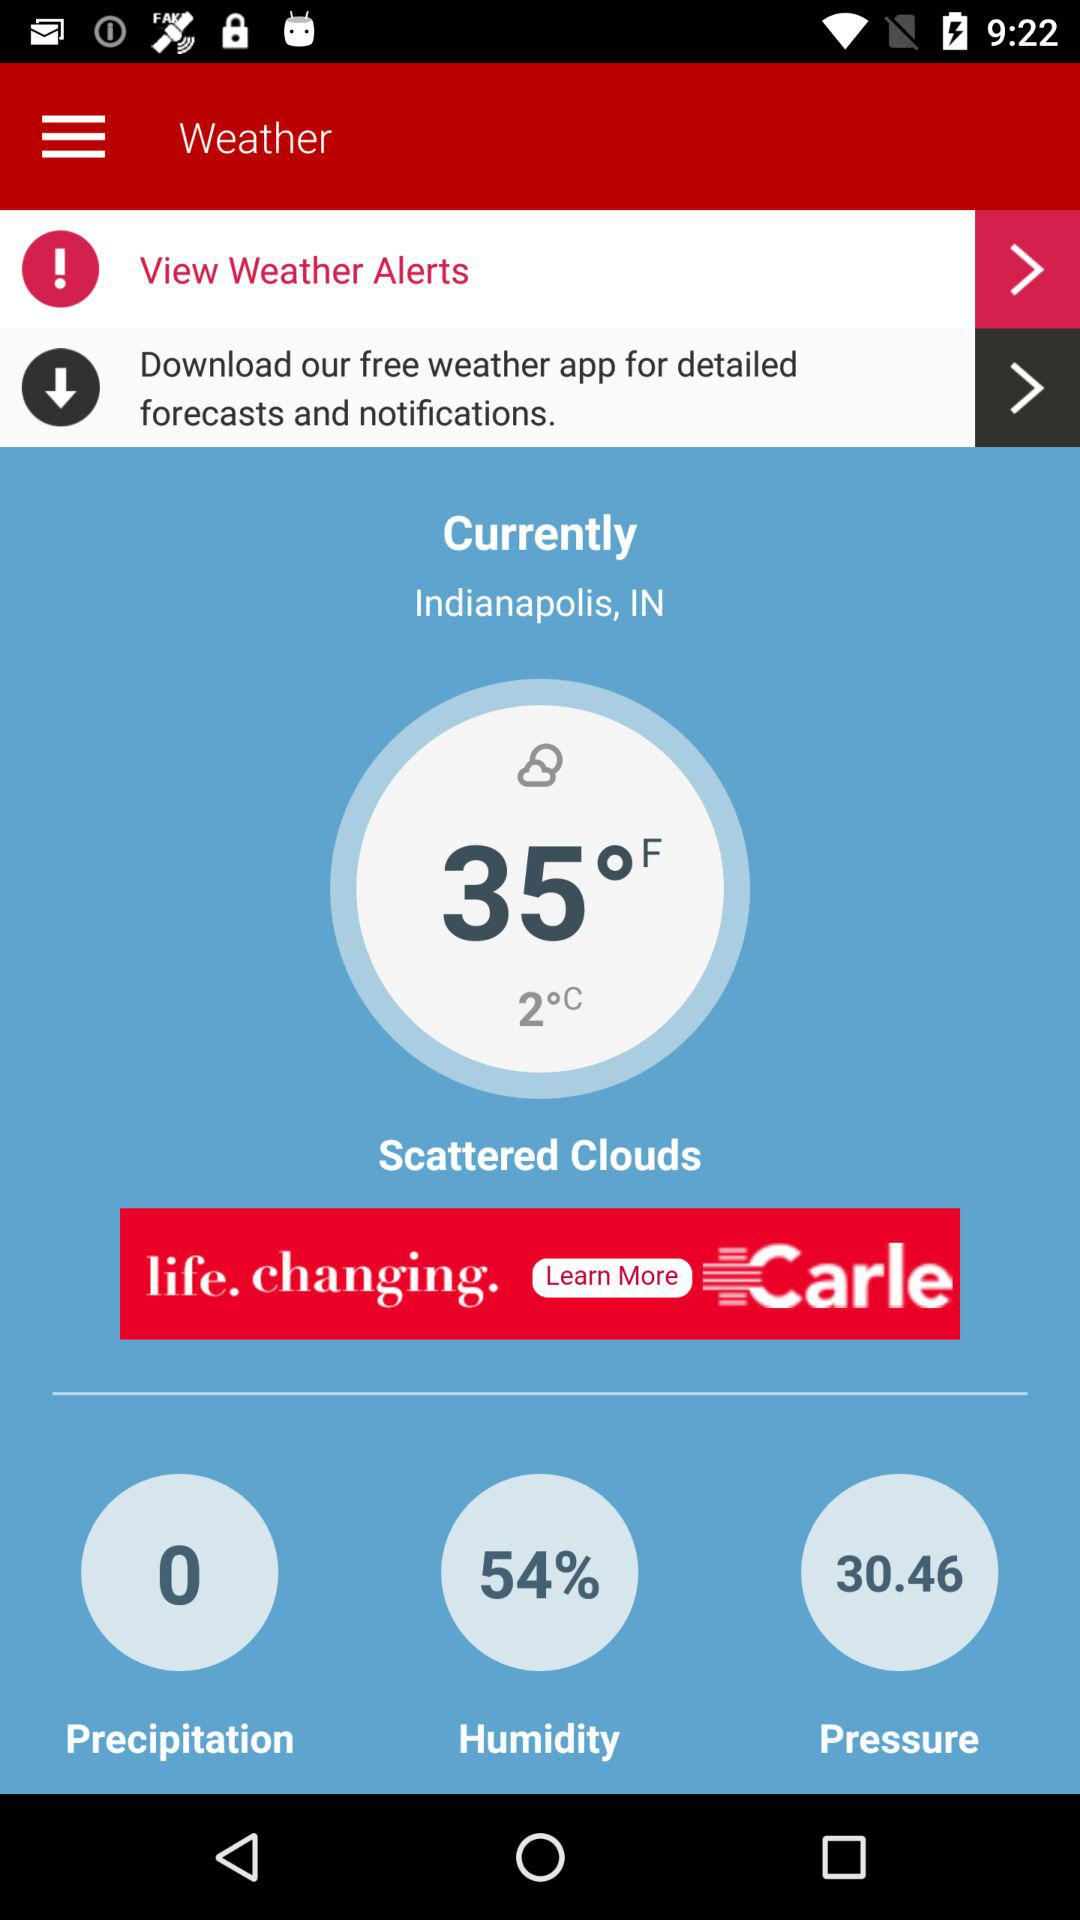What is the temperature given in Fahrenheit? The temperature is 35° Fahrenheit. 